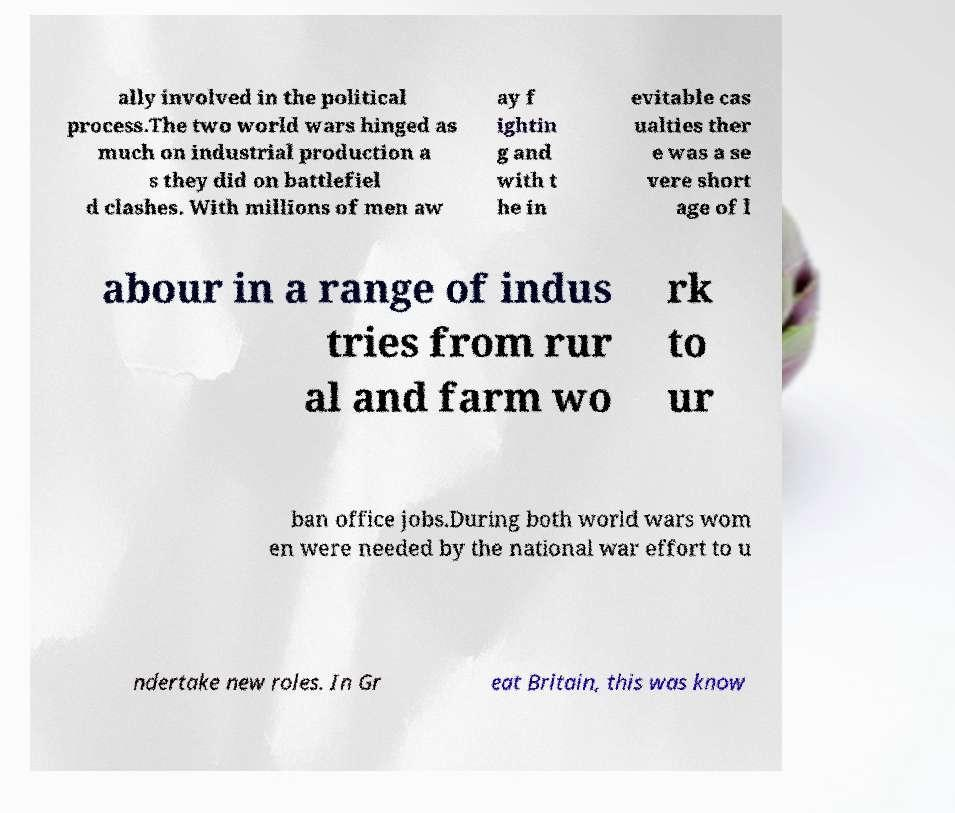I need the written content from this picture converted into text. Can you do that? ally involved in the political process.The two world wars hinged as much on industrial production a s they did on battlefiel d clashes. With millions of men aw ay f ightin g and with t he in evitable cas ualties ther e was a se vere short age of l abour in a range of indus tries from rur al and farm wo rk to ur ban office jobs.During both world wars wom en were needed by the national war effort to u ndertake new roles. In Gr eat Britain, this was know 